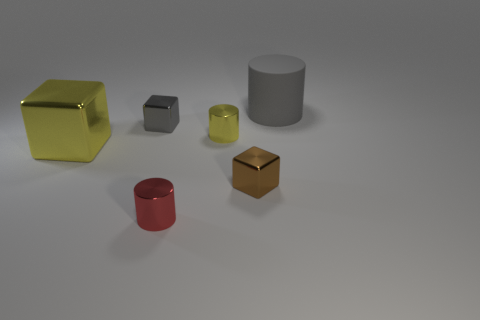Are there any other things that have the same material as the large gray cylinder? Yes, the material of the large gray cylinder appears to be reflective and matte, similar to the smaller gray cube. Materials with these characteristics tend to be of a metallic or plastic nature, and each object in the image seems to share a similar surface quality suggesting they could very well be made of the same or similar materials. 